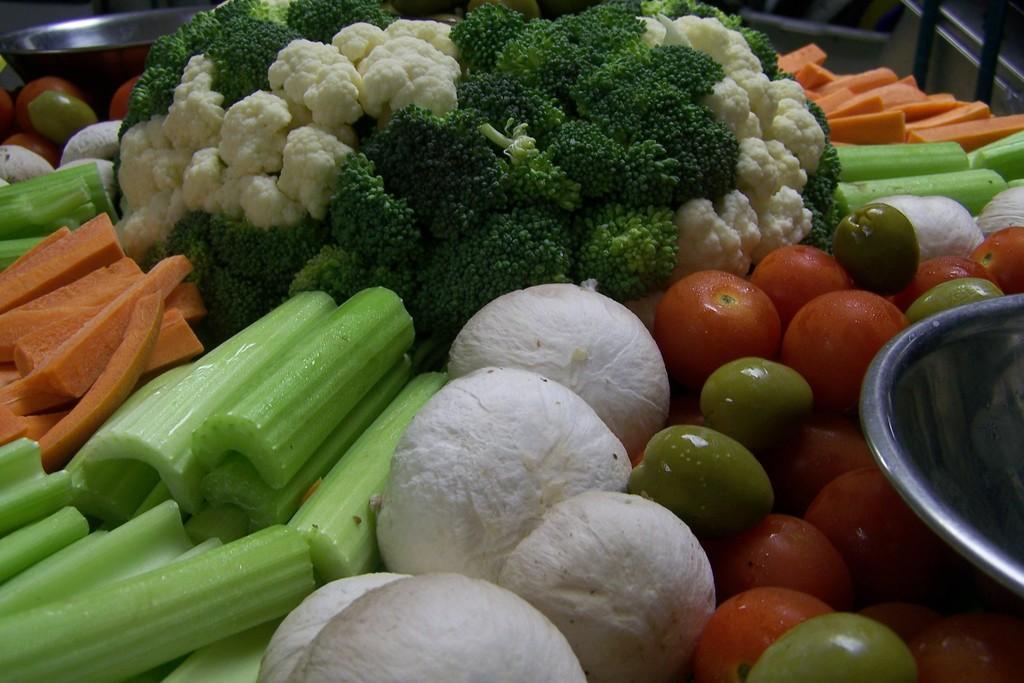Could you give a brief overview of what you see in this image? In this image we can see vegetables, here are the carrots, here is the cauliflower, here are the tomatoes, here are some vegetables, here is the bowl. 